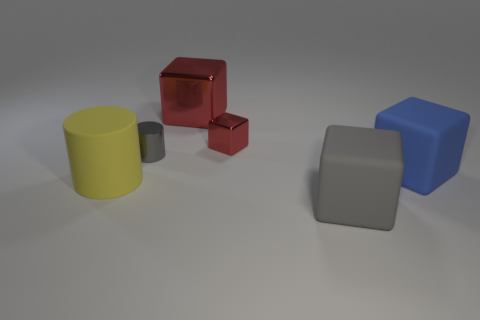Subtract all large gray blocks. How many blocks are left? 3 Subtract all yellow cylinders. How many cylinders are left? 1 Subtract all cylinders. How many objects are left? 4 Add 3 gray blocks. How many objects exist? 9 Subtract 1 cubes. How many cubes are left? 3 Add 4 red objects. How many red objects are left? 6 Add 6 large rubber things. How many large rubber things exist? 9 Subtract 0 yellow cubes. How many objects are left? 6 Subtract all gray blocks. Subtract all blue cylinders. How many blocks are left? 3 Subtract all green balls. How many yellow blocks are left? 0 